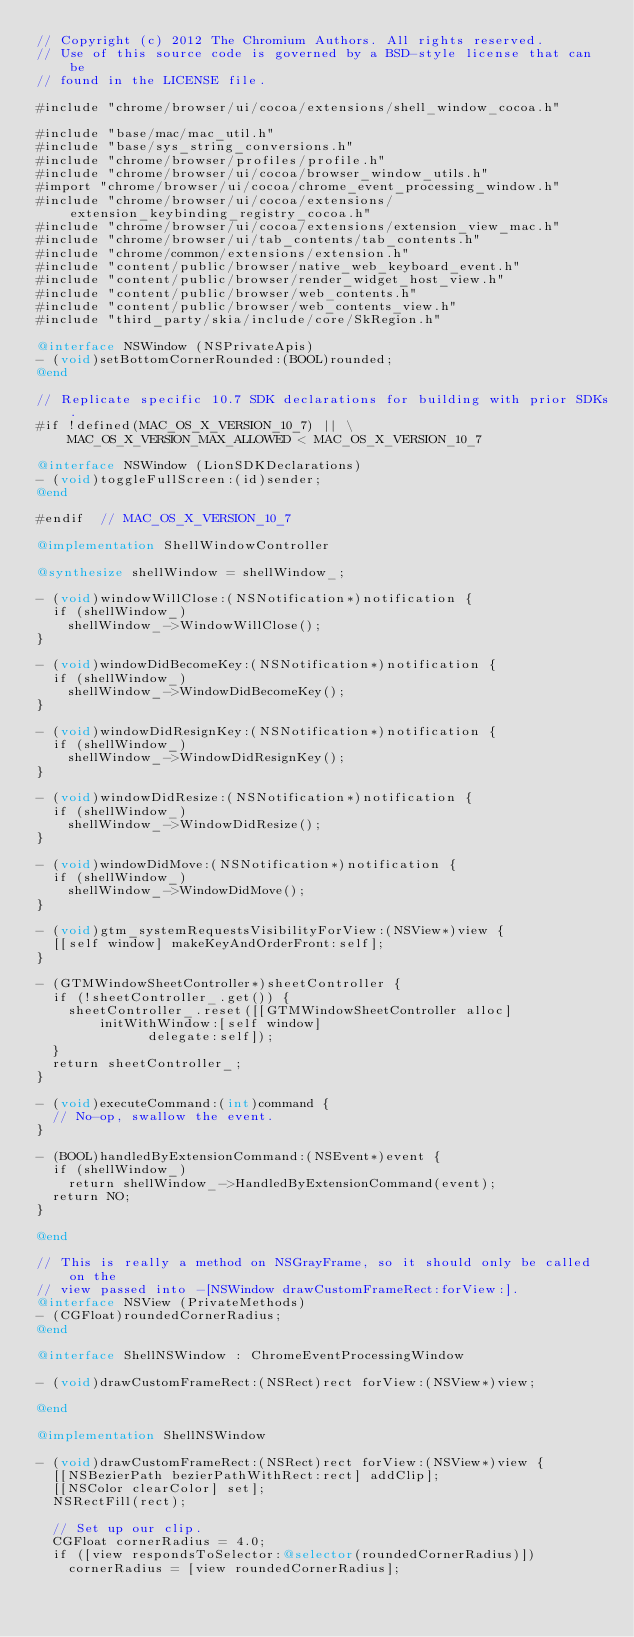<code> <loc_0><loc_0><loc_500><loc_500><_ObjectiveC_>// Copyright (c) 2012 The Chromium Authors. All rights reserved.
// Use of this source code is governed by a BSD-style license that can be
// found in the LICENSE file.

#include "chrome/browser/ui/cocoa/extensions/shell_window_cocoa.h"

#include "base/mac/mac_util.h"
#include "base/sys_string_conversions.h"
#include "chrome/browser/profiles/profile.h"
#include "chrome/browser/ui/cocoa/browser_window_utils.h"
#import "chrome/browser/ui/cocoa/chrome_event_processing_window.h"
#include "chrome/browser/ui/cocoa/extensions/extension_keybinding_registry_cocoa.h"
#include "chrome/browser/ui/cocoa/extensions/extension_view_mac.h"
#include "chrome/browser/ui/tab_contents/tab_contents.h"
#include "chrome/common/extensions/extension.h"
#include "content/public/browser/native_web_keyboard_event.h"
#include "content/public/browser/render_widget_host_view.h"
#include "content/public/browser/web_contents.h"
#include "content/public/browser/web_contents_view.h"
#include "third_party/skia/include/core/SkRegion.h"

@interface NSWindow (NSPrivateApis)
- (void)setBottomCornerRounded:(BOOL)rounded;
@end

// Replicate specific 10.7 SDK declarations for building with prior SDKs.
#if !defined(MAC_OS_X_VERSION_10_7) || \
    MAC_OS_X_VERSION_MAX_ALLOWED < MAC_OS_X_VERSION_10_7

@interface NSWindow (LionSDKDeclarations)
- (void)toggleFullScreen:(id)sender;
@end

#endif  // MAC_OS_X_VERSION_10_7

@implementation ShellWindowController

@synthesize shellWindow = shellWindow_;

- (void)windowWillClose:(NSNotification*)notification {
  if (shellWindow_)
    shellWindow_->WindowWillClose();
}

- (void)windowDidBecomeKey:(NSNotification*)notification {
  if (shellWindow_)
    shellWindow_->WindowDidBecomeKey();
}

- (void)windowDidResignKey:(NSNotification*)notification {
  if (shellWindow_)
    shellWindow_->WindowDidResignKey();
}

- (void)windowDidResize:(NSNotification*)notification {
  if (shellWindow_)
    shellWindow_->WindowDidResize();
}

- (void)windowDidMove:(NSNotification*)notification {
  if (shellWindow_)
    shellWindow_->WindowDidMove();
}

- (void)gtm_systemRequestsVisibilityForView:(NSView*)view {
  [[self window] makeKeyAndOrderFront:self];
}

- (GTMWindowSheetController*)sheetController {
  if (!sheetController_.get()) {
    sheetController_.reset([[GTMWindowSheetController alloc]
        initWithWindow:[self window]
              delegate:self]);
  }
  return sheetController_;
}

- (void)executeCommand:(int)command {
  // No-op, swallow the event.
}

- (BOOL)handledByExtensionCommand:(NSEvent*)event {
  if (shellWindow_)
    return shellWindow_->HandledByExtensionCommand(event);
  return NO;
}

@end

// This is really a method on NSGrayFrame, so it should only be called on the
// view passed into -[NSWindow drawCustomFrameRect:forView:].
@interface NSView (PrivateMethods)
- (CGFloat)roundedCornerRadius;
@end

@interface ShellNSWindow : ChromeEventProcessingWindow

- (void)drawCustomFrameRect:(NSRect)rect forView:(NSView*)view;

@end

@implementation ShellNSWindow

- (void)drawCustomFrameRect:(NSRect)rect forView:(NSView*)view {
  [[NSBezierPath bezierPathWithRect:rect] addClip];
  [[NSColor clearColor] set];
  NSRectFill(rect);

  // Set up our clip.
  CGFloat cornerRadius = 4.0;
  if ([view respondsToSelector:@selector(roundedCornerRadius)])
    cornerRadius = [view roundedCornerRadius];</code> 